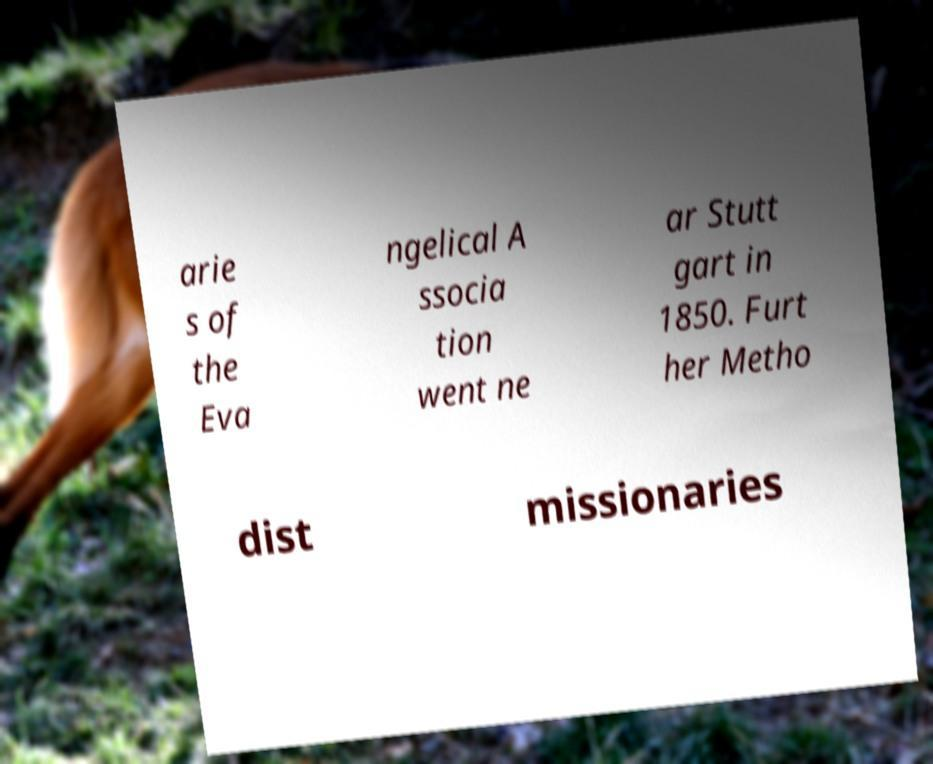Please identify and transcribe the text found in this image. arie s of the Eva ngelical A ssocia tion went ne ar Stutt gart in 1850. Furt her Metho dist missionaries 